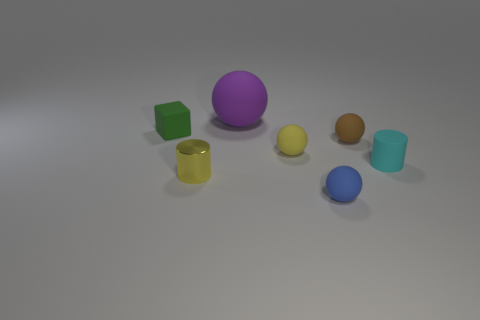Imagine this is a part of a larger set, what could these objects be used for? These objects might be part of a child's educational toy set designed to teach about shapes, colors, and sizes, or they could be used in a physics simulation to study objects' behaviors under various conditions. 